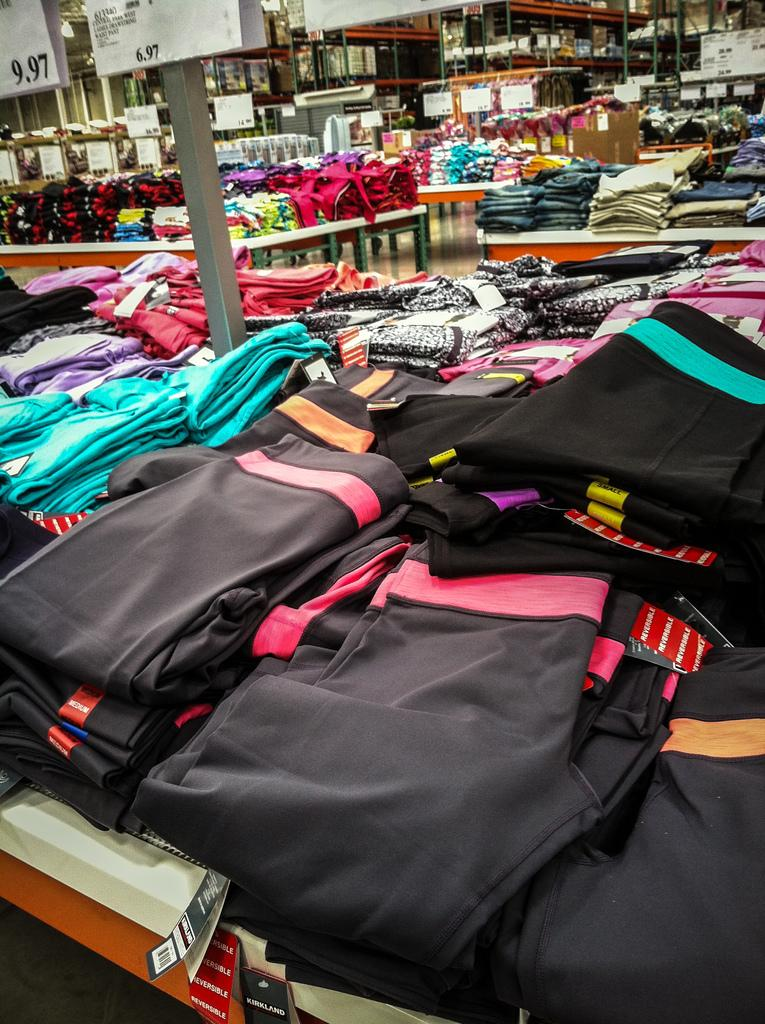What objects are present in the image? There are clothes in the image. Where are the clothes located? The clothes are placed on a table. What type of impulse can be seen affecting the clothes in the image? There is no impulse affecting the clothes in the image; they are simply placed on the table. What type of blade is visible in the image? There is no blade present in the image. 